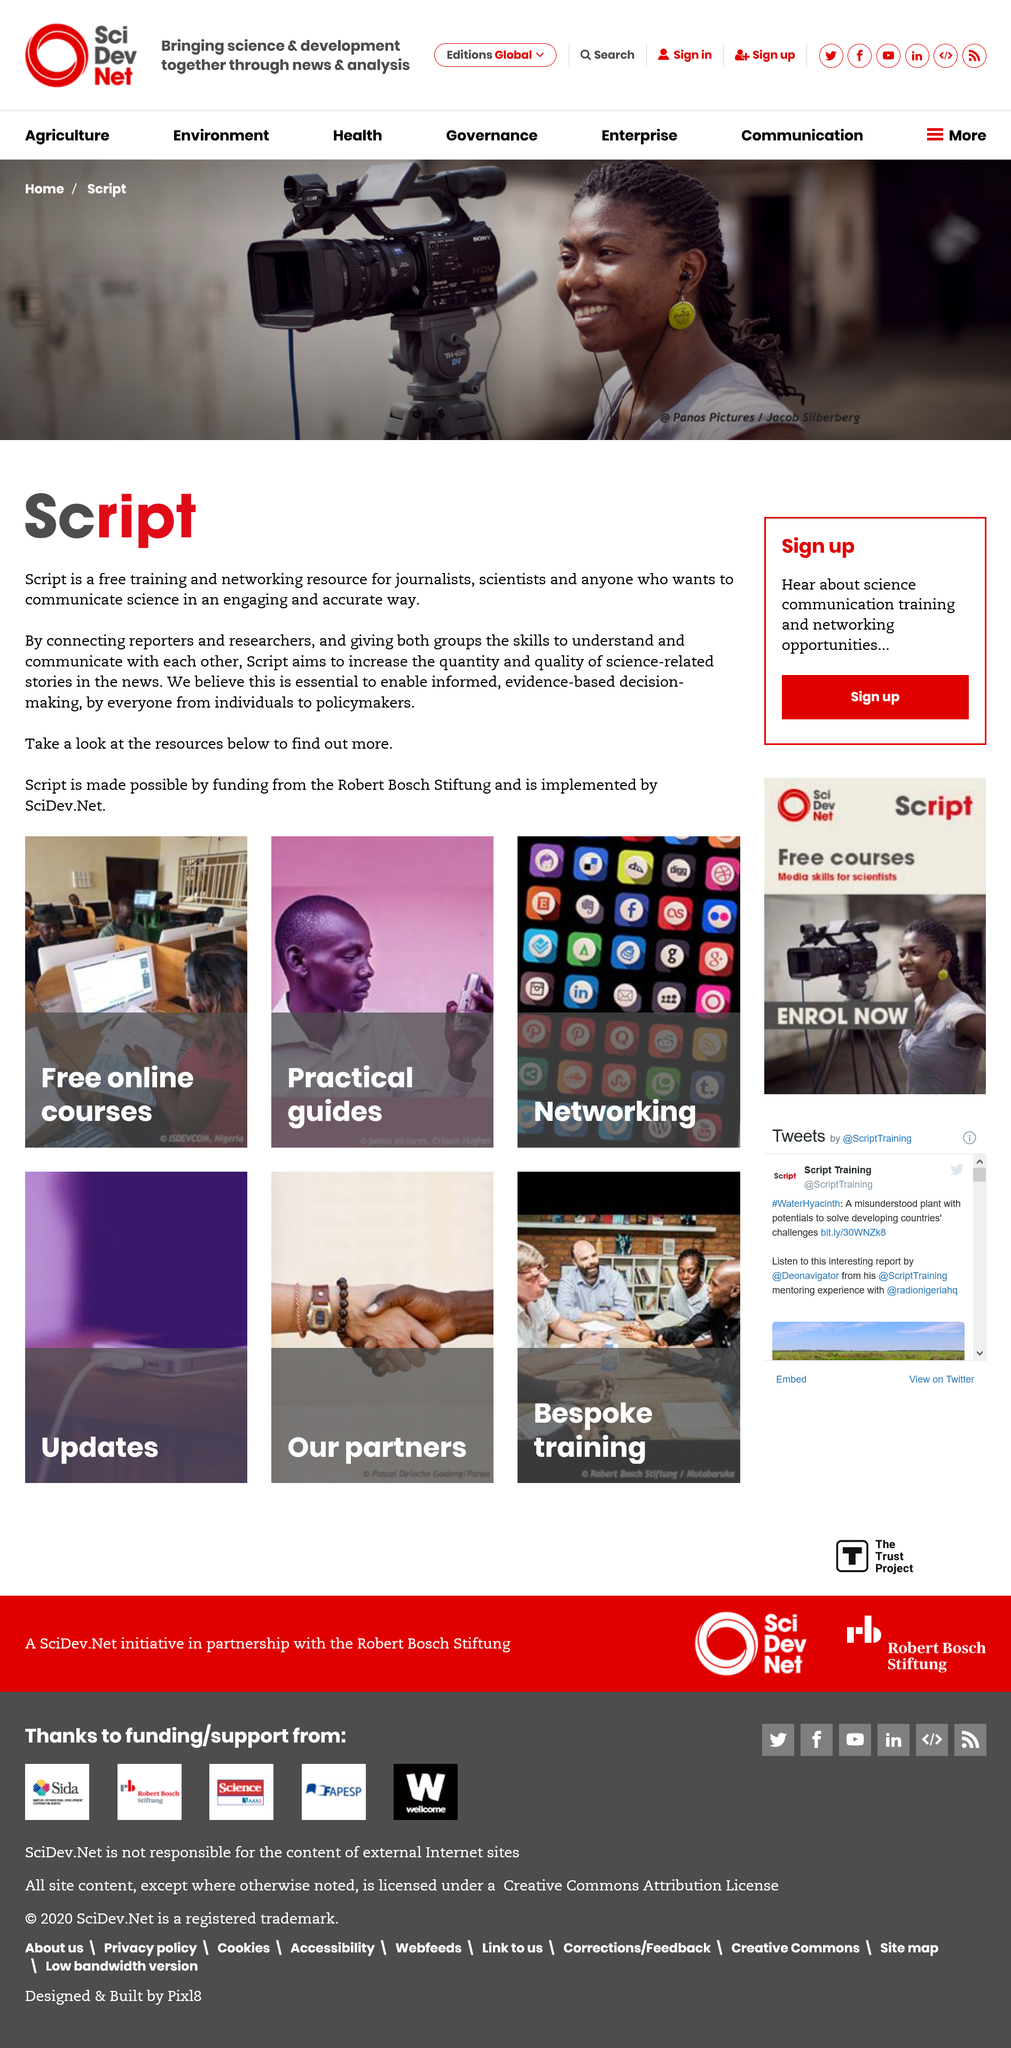List a handful of essential elements in this visual. We are grateful for the financial support provided by the Robert Bosch Stiftung, which has made the creation of this script possible. Script claims to connect two groups of people, namely reporters and researchers, and give both groups the skills to understand and communicate with each other. Script does offer free online courses, and this fact is undeniable. 